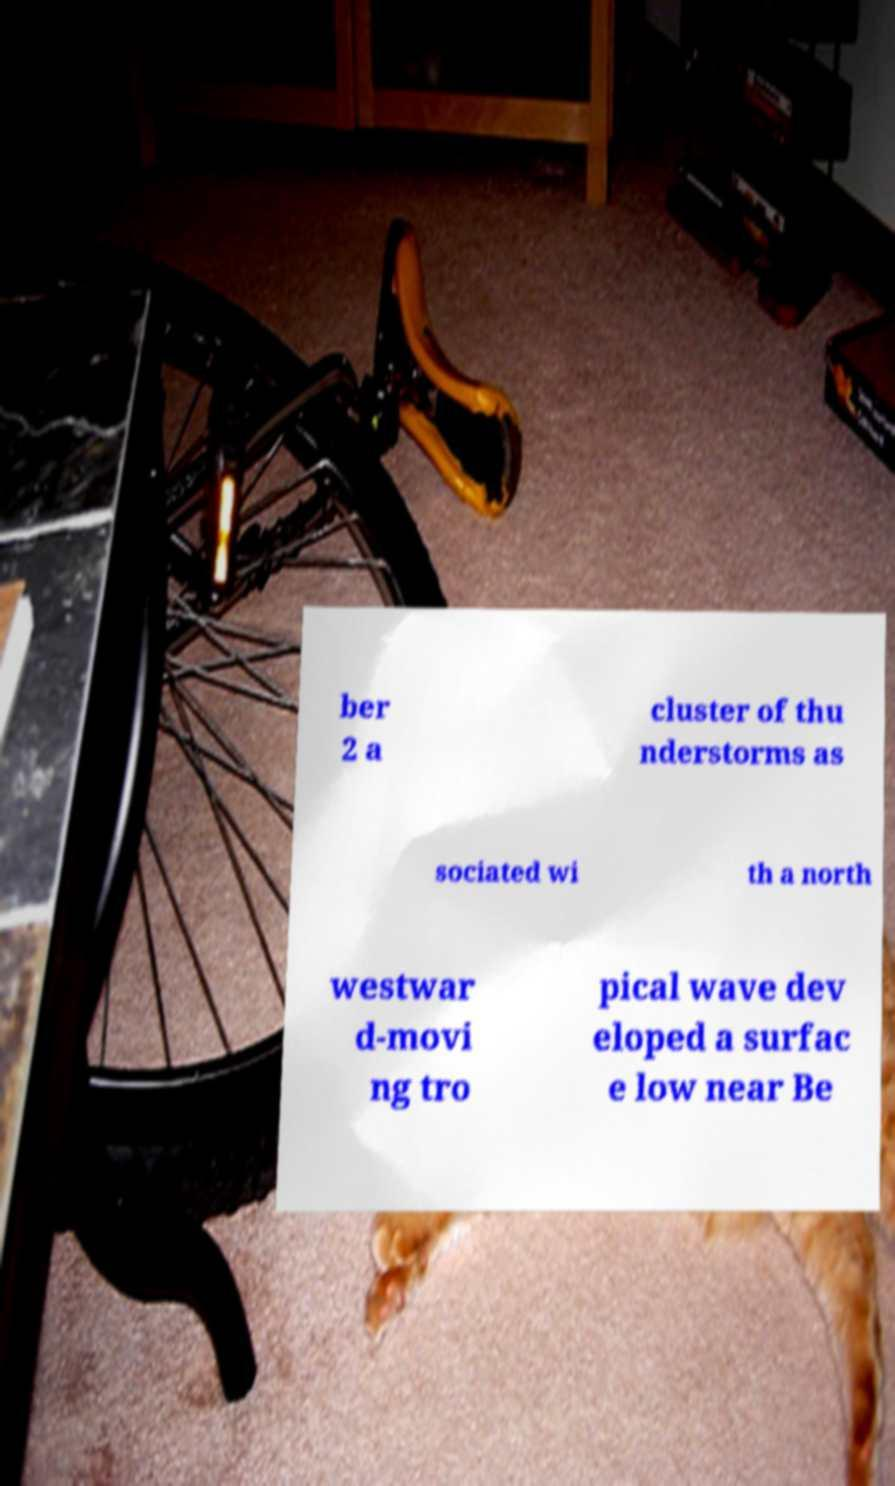What messages or text are displayed in this image? I need them in a readable, typed format. ber 2 a cluster of thu nderstorms as sociated wi th a north westwar d-movi ng tro pical wave dev eloped a surfac e low near Be 